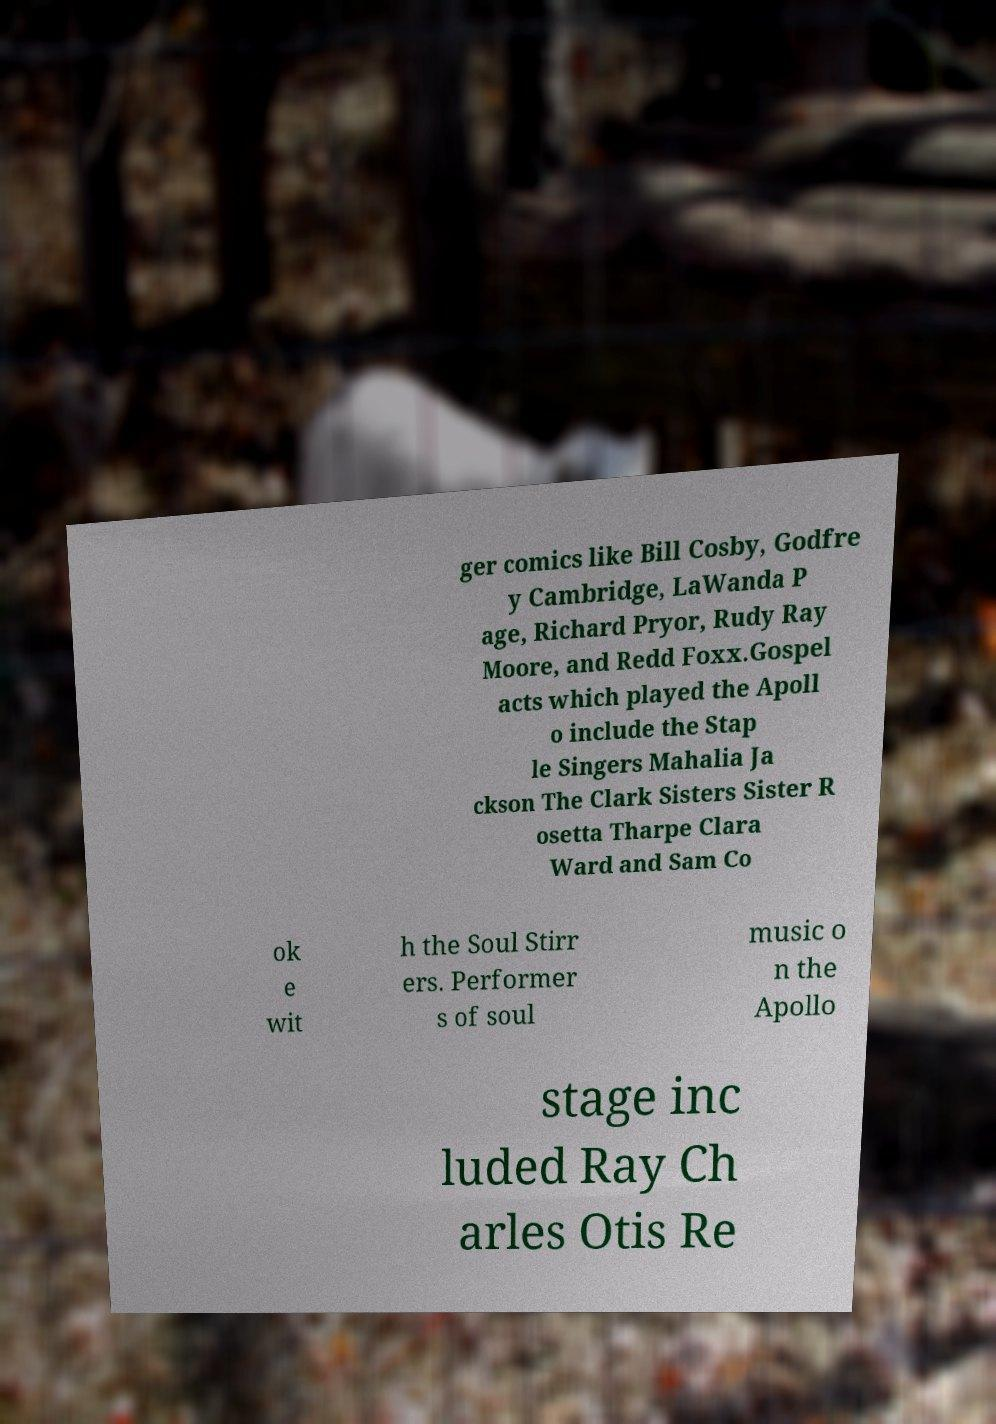Please identify and transcribe the text found in this image. ger comics like Bill Cosby, Godfre y Cambridge, LaWanda P age, Richard Pryor, Rudy Ray Moore, and Redd Foxx.Gospel acts which played the Apoll o include the Stap le Singers Mahalia Ja ckson The Clark Sisters Sister R osetta Tharpe Clara Ward and Sam Co ok e wit h the Soul Stirr ers. Performer s of soul music o n the Apollo stage inc luded Ray Ch arles Otis Re 